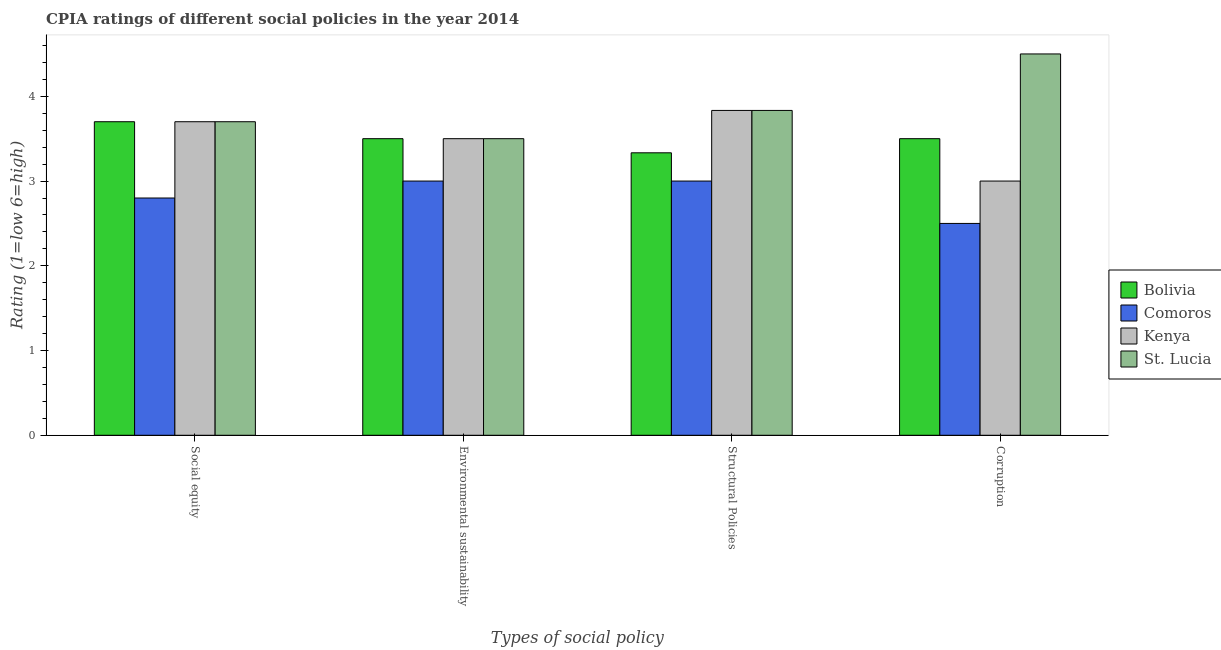How many different coloured bars are there?
Ensure brevity in your answer.  4. How many bars are there on the 1st tick from the left?
Your answer should be very brief. 4. How many bars are there on the 1st tick from the right?
Your response must be concise. 4. What is the label of the 3rd group of bars from the left?
Provide a short and direct response. Structural Policies. What is the cpia rating of structural policies in St. Lucia?
Your answer should be compact. 3.83. Across all countries, what is the maximum cpia rating of structural policies?
Your response must be concise. 3.83. Across all countries, what is the minimum cpia rating of environmental sustainability?
Ensure brevity in your answer.  3. In which country was the cpia rating of structural policies maximum?
Your answer should be compact. Kenya. In which country was the cpia rating of structural policies minimum?
Offer a terse response. Comoros. What is the total cpia rating of social equity in the graph?
Ensure brevity in your answer.  13.9. What is the difference between the cpia rating of social equity in Bolivia and that in Comoros?
Offer a terse response. 0.9. What is the difference between the cpia rating of social equity in St. Lucia and the cpia rating of corruption in Comoros?
Your answer should be very brief. 1.2. What is the average cpia rating of social equity per country?
Provide a succinct answer. 3.47. What is the difference between the cpia rating of corruption and cpia rating of social equity in Kenya?
Offer a terse response. -0.7. In how many countries, is the cpia rating of corruption greater than 0.4 ?
Your response must be concise. 4. What is the ratio of the cpia rating of corruption in Comoros to that in St. Lucia?
Your answer should be compact. 0.56. Is the cpia rating of social equity in St. Lucia less than that in Kenya?
Give a very brief answer. No. Is the difference between the cpia rating of corruption in Bolivia and Kenya greater than the difference between the cpia rating of environmental sustainability in Bolivia and Kenya?
Give a very brief answer. Yes. In how many countries, is the cpia rating of environmental sustainability greater than the average cpia rating of environmental sustainability taken over all countries?
Ensure brevity in your answer.  3. Is the sum of the cpia rating of corruption in Bolivia and Comoros greater than the maximum cpia rating of environmental sustainability across all countries?
Provide a succinct answer. Yes. Is it the case that in every country, the sum of the cpia rating of structural policies and cpia rating of corruption is greater than the sum of cpia rating of social equity and cpia rating of environmental sustainability?
Ensure brevity in your answer.  No. What does the 3rd bar from the left in Environmental sustainability represents?
Provide a succinct answer. Kenya. Are all the bars in the graph horizontal?
Your response must be concise. No. Are the values on the major ticks of Y-axis written in scientific E-notation?
Your response must be concise. No. Does the graph contain any zero values?
Offer a terse response. No. Where does the legend appear in the graph?
Offer a terse response. Center right. How many legend labels are there?
Give a very brief answer. 4. What is the title of the graph?
Provide a short and direct response. CPIA ratings of different social policies in the year 2014. What is the label or title of the X-axis?
Your answer should be compact. Types of social policy. What is the label or title of the Y-axis?
Your response must be concise. Rating (1=low 6=high). What is the Rating (1=low 6=high) in Bolivia in Environmental sustainability?
Provide a short and direct response. 3.5. What is the Rating (1=low 6=high) of Comoros in Environmental sustainability?
Your answer should be very brief. 3. What is the Rating (1=low 6=high) in Bolivia in Structural Policies?
Ensure brevity in your answer.  3.33. What is the Rating (1=low 6=high) of Comoros in Structural Policies?
Keep it short and to the point. 3. What is the Rating (1=low 6=high) in Kenya in Structural Policies?
Make the answer very short. 3.83. What is the Rating (1=low 6=high) of St. Lucia in Structural Policies?
Ensure brevity in your answer.  3.83. What is the Rating (1=low 6=high) in Bolivia in Corruption?
Provide a short and direct response. 3.5. What is the Rating (1=low 6=high) in Comoros in Corruption?
Keep it short and to the point. 2.5. What is the Rating (1=low 6=high) in Kenya in Corruption?
Provide a short and direct response. 3. Across all Types of social policy, what is the maximum Rating (1=low 6=high) in Bolivia?
Offer a very short reply. 3.7. Across all Types of social policy, what is the maximum Rating (1=low 6=high) of Kenya?
Keep it short and to the point. 3.83. Across all Types of social policy, what is the minimum Rating (1=low 6=high) in Bolivia?
Keep it short and to the point. 3.33. Across all Types of social policy, what is the minimum Rating (1=low 6=high) of Comoros?
Provide a succinct answer. 2.5. Across all Types of social policy, what is the minimum Rating (1=low 6=high) in Kenya?
Your answer should be very brief. 3. What is the total Rating (1=low 6=high) in Bolivia in the graph?
Make the answer very short. 14.03. What is the total Rating (1=low 6=high) in Kenya in the graph?
Offer a very short reply. 14.03. What is the total Rating (1=low 6=high) in St. Lucia in the graph?
Provide a succinct answer. 15.53. What is the difference between the Rating (1=low 6=high) of Bolivia in Social equity and that in Environmental sustainability?
Your answer should be very brief. 0.2. What is the difference between the Rating (1=low 6=high) of Comoros in Social equity and that in Environmental sustainability?
Keep it short and to the point. -0.2. What is the difference between the Rating (1=low 6=high) in Bolivia in Social equity and that in Structural Policies?
Give a very brief answer. 0.37. What is the difference between the Rating (1=low 6=high) of Comoros in Social equity and that in Structural Policies?
Offer a very short reply. -0.2. What is the difference between the Rating (1=low 6=high) of Kenya in Social equity and that in Structural Policies?
Make the answer very short. -0.13. What is the difference between the Rating (1=low 6=high) in St. Lucia in Social equity and that in Structural Policies?
Ensure brevity in your answer.  -0.13. What is the difference between the Rating (1=low 6=high) of Bolivia in Social equity and that in Corruption?
Give a very brief answer. 0.2. What is the difference between the Rating (1=low 6=high) in Comoros in Social equity and that in Corruption?
Your response must be concise. 0.3. What is the difference between the Rating (1=low 6=high) of Kenya in Social equity and that in Corruption?
Offer a terse response. 0.7. What is the difference between the Rating (1=low 6=high) in Bolivia in Environmental sustainability and that in Structural Policies?
Make the answer very short. 0.17. What is the difference between the Rating (1=low 6=high) in St. Lucia in Environmental sustainability and that in Structural Policies?
Keep it short and to the point. -0.33. What is the difference between the Rating (1=low 6=high) of Bolivia in Environmental sustainability and that in Corruption?
Offer a very short reply. 0. What is the difference between the Rating (1=low 6=high) in Kenya in Structural Policies and that in Corruption?
Your answer should be very brief. 0.83. What is the difference between the Rating (1=low 6=high) of Bolivia in Social equity and the Rating (1=low 6=high) of St. Lucia in Environmental sustainability?
Your response must be concise. 0.2. What is the difference between the Rating (1=low 6=high) in Bolivia in Social equity and the Rating (1=low 6=high) in Comoros in Structural Policies?
Your response must be concise. 0.7. What is the difference between the Rating (1=low 6=high) of Bolivia in Social equity and the Rating (1=low 6=high) of Kenya in Structural Policies?
Your response must be concise. -0.13. What is the difference between the Rating (1=low 6=high) of Bolivia in Social equity and the Rating (1=low 6=high) of St. Lucia in Structural Policies?
Your response must be concise. -0.13. What is the difference between the Rating (1=low 6=high) in Comoros in Social equity and the Rating (1=low 6=high) in Kenya in Structural Policies?
Your response must be concise. -1.03. What is the difference between the Rating (1=low 6=high) in Comoros in Social equity and the Rating (1=low 6=high) in St. Lucia in Structural Policies?
Give a very brief answer. -1.03. What is the difference between the Rating (1=low 6=high) of Kenya in Social equity and the Rating (1=low 6=high) of St. Lucia in Structural Policies?
Give a very brief answer. -0.13. What is the difference between the Rating (1=low 6=high) in Bolivia in Social equity and the Rating (1=low 6=high) in Kenya in Corruption?
Offer a terse response. 0.7. What is the difference between the Rating (1=low 6=high) of Bolivia in Social equity and the Rating (1=low 6=high) of St. Lucia in Corruption?
Offer a very short reply. -0.8. What is the difference between the Rating (1=low 6=high) of Comoros in Social equity and the Rating (1=low 6=high) of Kenya in Corruption?
Ensure brevity in your answer.  -0.2. What is the difference between the Rating (1=low 6=high) in Comoros in Social equity and the Rating (1=low 6=high) in St. Lucia in Corruption?
Offer a very short reply. -1.7. What is the difference between the Rating (1=low 6=high) of Comoros in Environmental sustainability and the Rating (1=low 6=high) of St. Lucia in Structural Policies?
Offer a terse response. -0.83. What is the difference between the Rating (1=low 6=high) of Kenya in Environmental sustainability and the Rating (1=low 6=high) of St. Lucia in Structural Policies?
Ensure brevity in your answer.  -0.33. What is the difference between the Rating (1=low 6=high) in Bolivia in Environmental sustainability and the Rating (1=low 6=high) in St. Lucia in Corruption?
Your answer should be compact. -1. What is the difference between the Rating (1=low 6=high) of Comoros in Environmental sustainability and the Rating (1=low 6=high) of St. Lucia in Corruption?
Provide a short and direct response. -1.5. What is the difference between the Rating (1=low 6=high) in Bolivia in Structural Policies and the Rating (1=low 6=high) in Comoros in Corruption?
Ensure brevity in your answer.  0.83. What is the difference between the Rating (1=low 6=high) in Bolivia in Structural Policies and the Rating (1=low 6=high) in Kenya in Corruption?
Keep it short and to the point. 0.33. What is the difference between the Rating (1=low 6=high) of Bolivia in Structural Policies and the Rating (1=low 6=high) of St. Lucia in Corruption?
Make the answer very short. -1.17. What is the difference between the Rating (1=low 6=high) of Comoros in Structural Policies and the Rating (1=low 6=high) of Kenya in Corruption?
Your answer should be compact. 0. What is the difference between the Rating (1=low 6=high) in Comoros in Structural Policies and the Rating (1=low 6=high) in St. Lucia in Corruption?
Your answer should be compact. -1.5. What is the difference between the Rating (1=low 6=high) of Kenya in Structural Policies and the Rating (1=low 6=high) of St. Lucia in Corruption?
Ensure brevity in your answer.  -0.67. What is the average Rating (1=low 6=high) of Bolivia per Types of social policy?
Your answer should be compact. 3.51. What is the average Rating (1=low 6=high) in Comoros per Types of social policy?
Provide a short and direct response. 2.83. What is the average Rating (1=low 6=high) in Kenya per Types of social policy?
Keep it short and to the point. 3.51. What is the average Rating (1=low 6=high) in St. Lucia per Types of social policy?
Offer a very short reply. 3.88. What is the difference between the Rating (1=low 6=high) of Bolivia and Rating (1=low 6=high) of Comoros in Social equity?
Provide a short and direct response. 0.9. What is the difference between the Rating (1=low 6=high) of Comoros and Rating (1=low 6=high) of Kenya in Social equity?
Offer a very short reply. -0.9. What is the difference between the Rating (1=low 6=high) in Comoros and Rating (1=low 6=high) in St. Lucia in Social equity?
Keep it short and to the point. -0.9. What is the difference between the Rating (1=low 6=high) of Kenya and Rating (1=low 6=high) of St. Lucia in Social equity?
Offer a very short reply. 0. What is the difference between the Rating (1=low 6=high) in Bolivia and Rating (1=low 6=high) in Comoros in Environmental sustainability?
Offer a very short reply. 0.5. What is the difference between the Rating (1=low 6=high) of Bolivia and Rating (1=low 6=high) of St. Lucia in Environmental sustainability?
Your answer should be compact. 0. What is the difference between the Rating (1=low 6=high) in Comoros and Rating (1=low 6=high) in Kenya in Environmental sustainability?
Make the answer very short. -0.5. What is the difference between the Rating (1=low 6=high) of Comoros and Rating (1=low 6=high) of St. Lucia in Environmental sustainability?
Your answer should be compact. -0.5. What is the difference between the Rating (1=low 6=high) in Kenya and Rating (1=low 6=high) in St. Lucia in Environmental sustainability?
Make the answer very short. 0. What is the difference between the Rating (1=low 6=high) in Bolivia and Rating (1=low 6=high) in St. Lucia in Structural Policies?
Provide a short and direct response. -0.5. What is the difference between the Rating (1=low 6=high) of Comoros and Rating (1=low 6=high) of Kenya in Structural Policies?
Offer a terse response. -0.83. What is the difference between the Rating (1=low 6=high) in Comoros and Rating (1=low 6=high) in St. Lucia in Structural Policies?
Your response must be concise. -0.83. What is the difference between the Rating (1=low 6=high) in Kenya and Rating (1=low 6=high) in St. Lucia in Structural Policies?
Offer a very short reply. 0. What is the difference between the Rating (1=low 6=high) in Bolivia and Rating (1=low 6=high) in Comoros in Corruption?
Offer a terse response. 1. What is the difference between the Rating (1=low 6=high) of Bolivia and Rating (1=low 6=high) of St. Lucia in Corruption?
Your response must be concise. -1. What is the difference between the Rating (1=low 6=high) of Comoros and Rating (1=low 6=high) of St. Lucia in Corruption?
Give a very brief answer. -2. What is the ratio of the Rating (1=low 6=high) of Bolivia in Social equity to that in Environmental sustainability?
Offer a terse response. 1.06. What is the ratio of the Rating (1=low 6=high) in Kenya in Social equity to that in Environmental sustainability?
Your response must be concise. 1.06. What is the ratio of the Rating (1=low 6=high) in St. Lucia in Social equity to that in Environmental sustainability?
Make the answer very short. 1.06. What is the ratio of the Rating (1=low 6=high) in Bolivia in Social equity to that in Structural Policies?
Ensure brevity in your answer.  1.11. What is the ratio of the Rating (1=low 6=high) in Comoros in Social equity to that in Structural Policies?
Make the answer very short. 0.93. What is the ratio of the Rating (1=low 6=high) in Kenya in Social equity to that in Structural Policies?
Keep it short and to the point. 0.97. What is the ratio of the Rating (1=low 6=high) in St. Lucia in Social equity to that in Structural Policies?
Provide a succinct answer. 0.97. What is the ratio of the Rating (1=low 6=high) in Bolivia in Social equity to that in Corruption?
Ensure brevity in your answer.  1.06. What is the ratio of the Rating (1=low 6=high) in Comoros in Social equity to that in Corruption?
Give a very brief answer. 1.12. What is the ratio of the Rating (1=low 6=high) of Kenya in Social equity to that in Corruption?
Your answer should be compact. 1.23. What is the ratio of the Rating (1=low 6=high) of St. Lucia in Social equity to that in Corruption?
Provide a short and direct response. 0.82. What is the ratio of the Rating (1=low 6=high) of Bolivia in Environmental sustainability to that in Structural Policies?
Provide a short and direct response. 1.05. What is the ratio of the Rating (1=low 6=high) in St. Lucia in Environmental sustainability to that in Structural Policies?
Your response must be concise. 0.91. What is the ratio of the Rating (1=low 6=high) in Comoros in Environmental sustainability to that in Corruption?
Give a very brief answer. 1.2. What is the ratio of the Rating (1=low 6=high) of Comoros in Structural Policies to that in Corruption?
Provide a short and direct response. 1.2. What is the ratio of the Rating (1=low 6=high) in Kenya in Structural Policies to that in Corruption?
Ensure brevity in your answer.  1.28. What is the ratio of the Rating (1=low 6=high) of St. Lucia in Structural Policies to that in Corruption?
Offer a very short reply. 0.85. What is the difference between the highest and the second highest Rating (1=low 6=high) of Comoros?
Ensure brevity in your answer.  0. What is the difference between the highest and the second highest Rating (1=low 6=high) of Kenya?
Ensure brevity in your answer.  0.13. What is the difference between the highest and the lowest Rating (1=low 6=high) in Bolivia?
Your response must be concise. 0.37. What is the difference between the highest and the lowest Rating (1=low 6=high) in St. Lucia?
Provide a short and direct response. 1. 